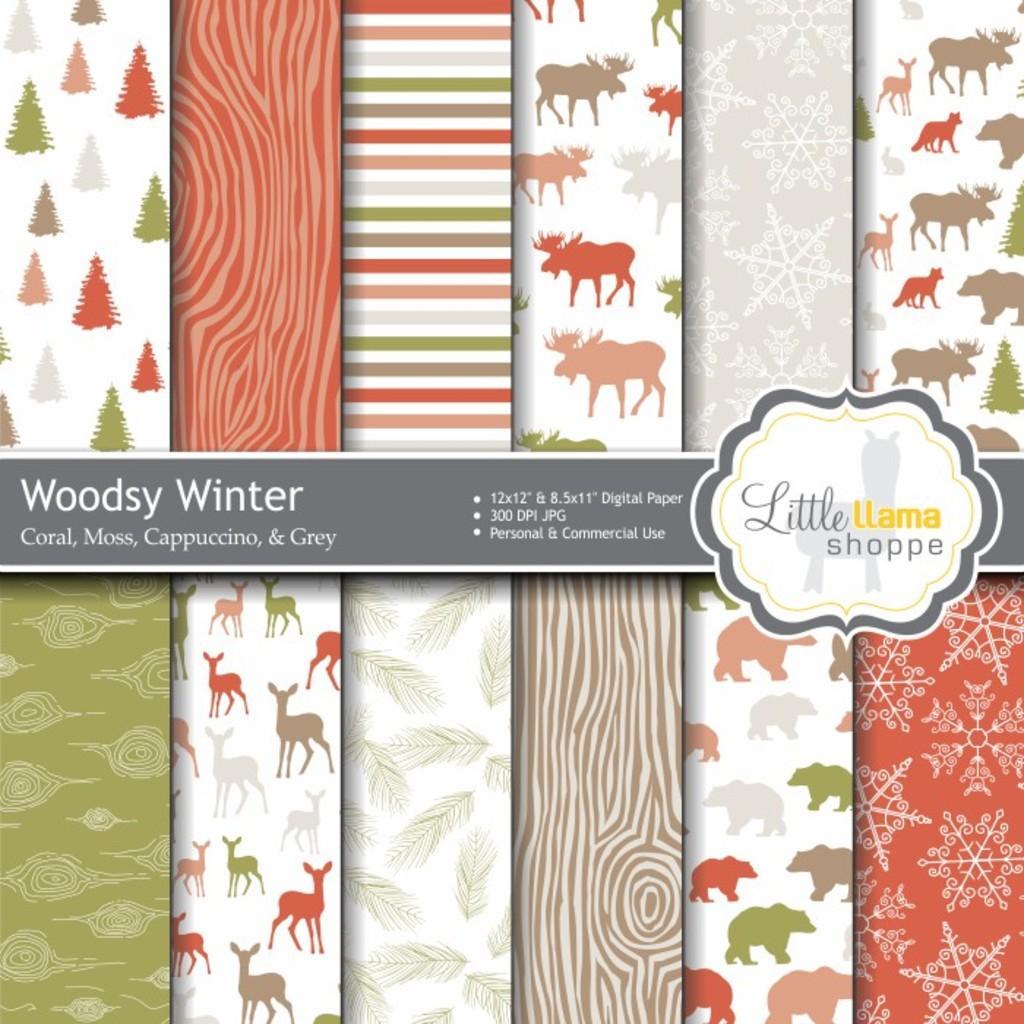Can you describe this image briefly? This is an advertisement. In the center of the image we can see a logo and text. In the background of the image we can see the different types of boards. 